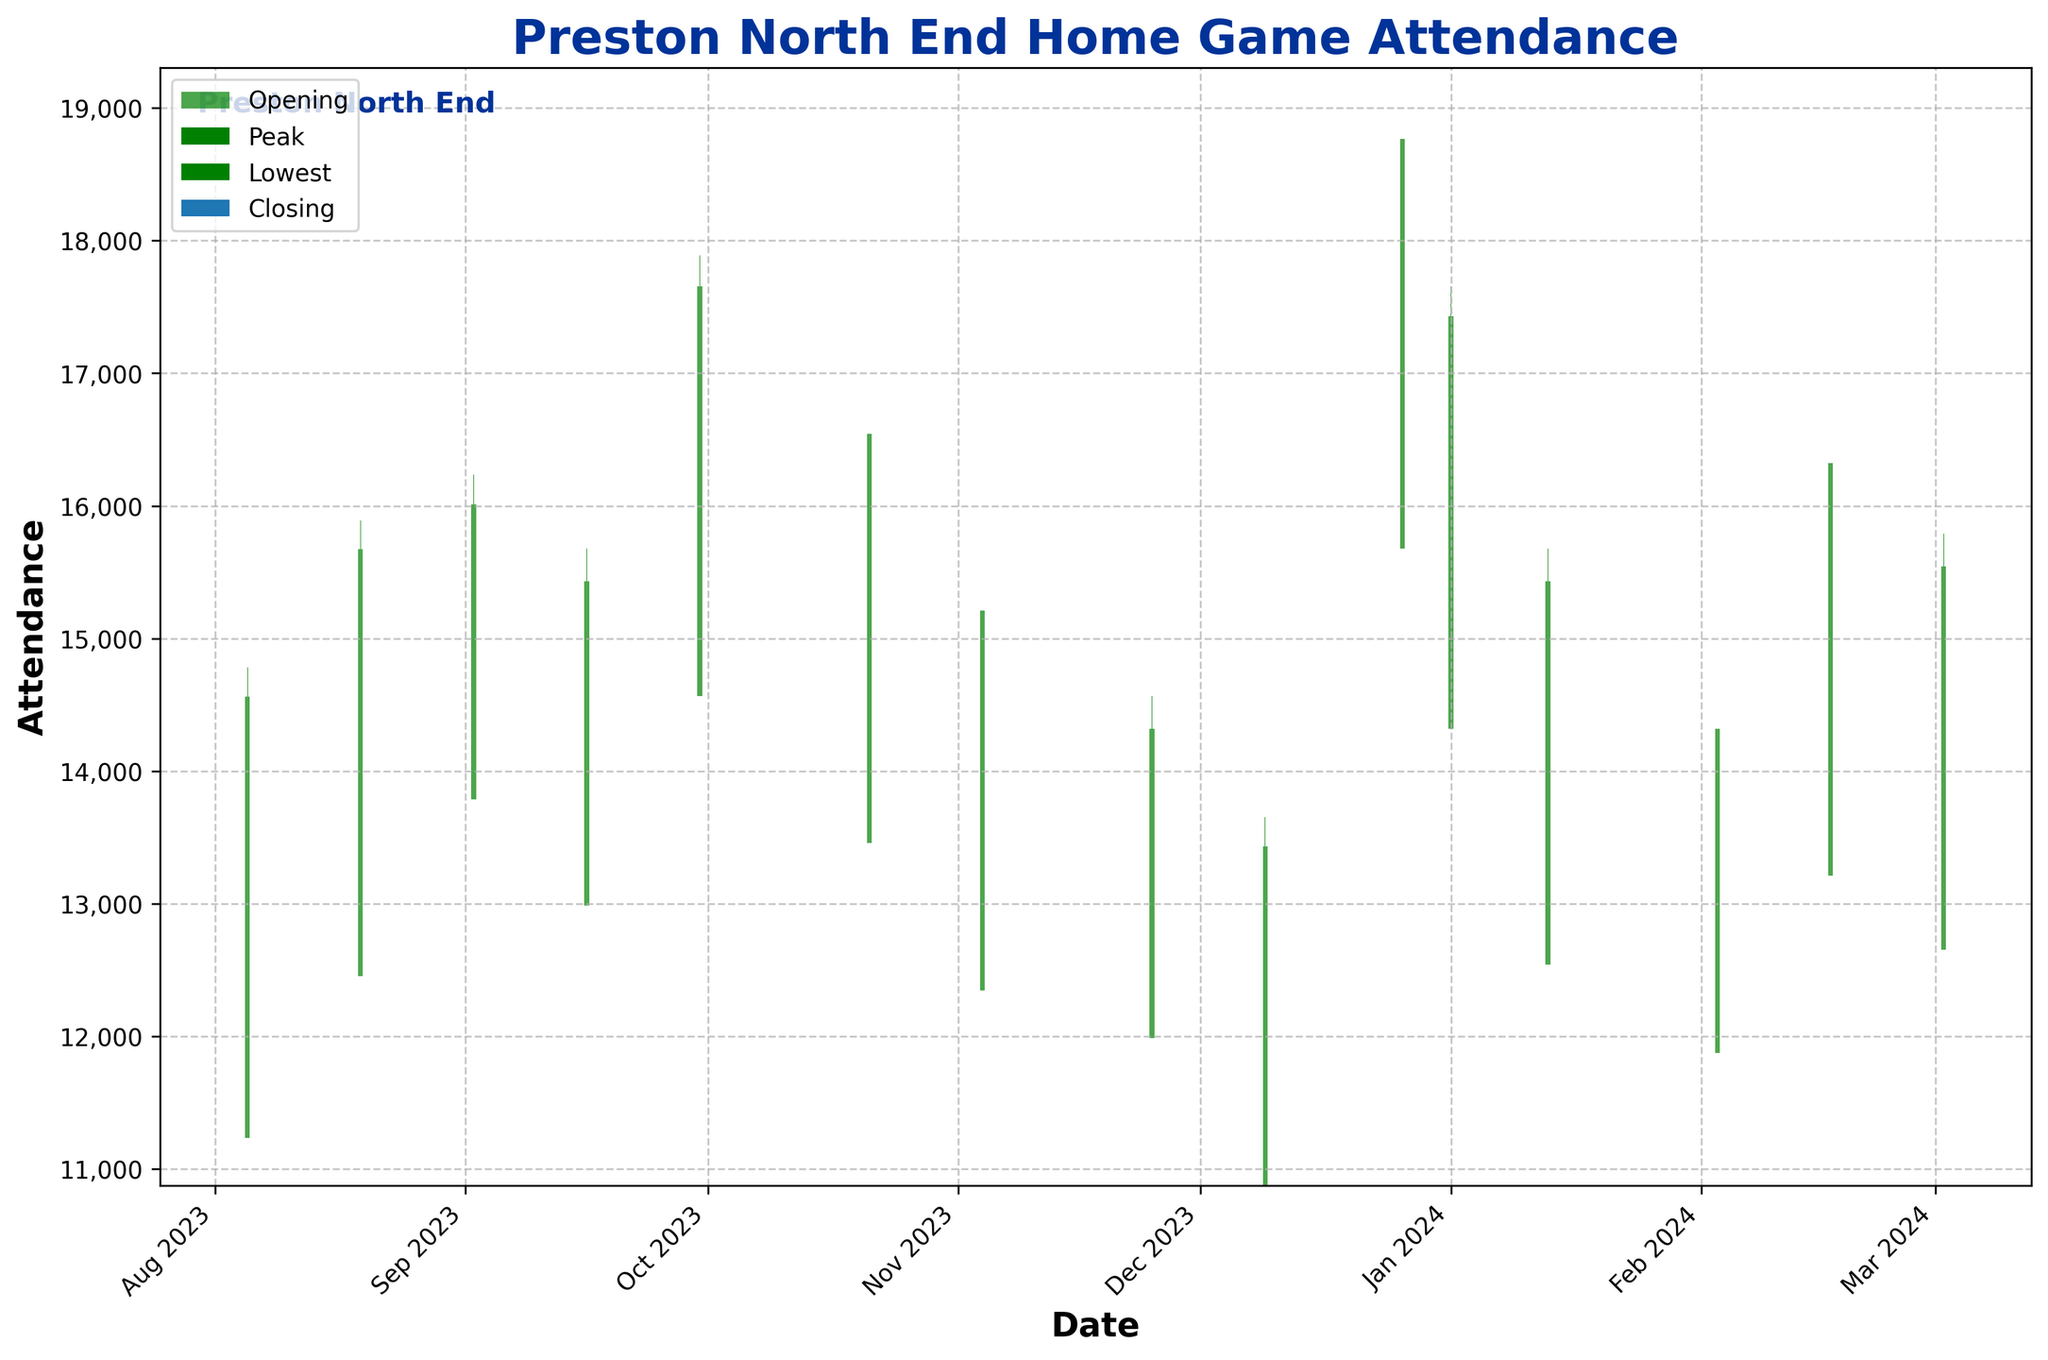What is the title of the figure? The title of the figure is prominently displayed at the top and reads "Preston North End Home Game Attendance."
Answer: Preston North End Home Game Attendance How many unique dates are plotted in the figure? By counting the number of distinct bars (representing each date), we can determine there are 15 unique dates.
Answer: 15 What is the highest peak attendance recorded, and on what date did it occur? The highest peak attendance is indicated by the tallest green or red vertical line. It occurred on December 26, 2023, with 18,901 attendees.
Answer: 18,901 on December 26, 2023 Which game had the lowest opening attendance, and what was the value? The game on December 9, 2023, had the lowest opening attendance, indicated by the lowest starting point of one of the green or red bars, at 10,876 attendees.
Answer: 10,876 on December 9, 2023 What was the closing attendance on January 1, 2024, and did it increase or decrease compared to the opening attendance? The closing attendance on January 1, 2024, is shown by the closing point of the bar for that date. It is 17,432, which is higher than the opening attendance of 14,321, indicating an increase.
Answer: 17,432, increase On which date was there the smallest difference between the peak and lowest attendance? By examining the heights of the green or red bars and comparing the differences between the peak and lowest attendance for each date, the date with the smallest difference is November 25, 2023.
Answer: November 25, 2023 What was the average closing attendance for the first three games? First, sum the closing attendances of the first three games: 14,562 + 15,673 + 16,012 = 46,247. Then divide by 3 to get the average: 46,247 / 3 ≈ 15,416.
Answer: 15,416 Which date saw the largest decrease from peak to closing attendance? Identify the date where the difference between the peak and closing attendance is the largest by visually inspecting the red or green vertical lines. The largest decrease appears on October 21, 2023.
Answer: October 21, 2023 How many games ended with a closing attendance higher than the opening attendance? Count the number of green bars, which indicate an increase (closing attendance higher than opening attendance). There are 10 such games.
Answer: 10 Comparing March 2, 2024, and February 17, 2024, which date had a higher peak attendance, and what are the values? By observing the heights of the peak points for each date, February 17, 2024, had a higher peak attendance at 16,543 compared to 15,789 on March 2, 2024.
Answer: February 17, 2024, with 16,543 